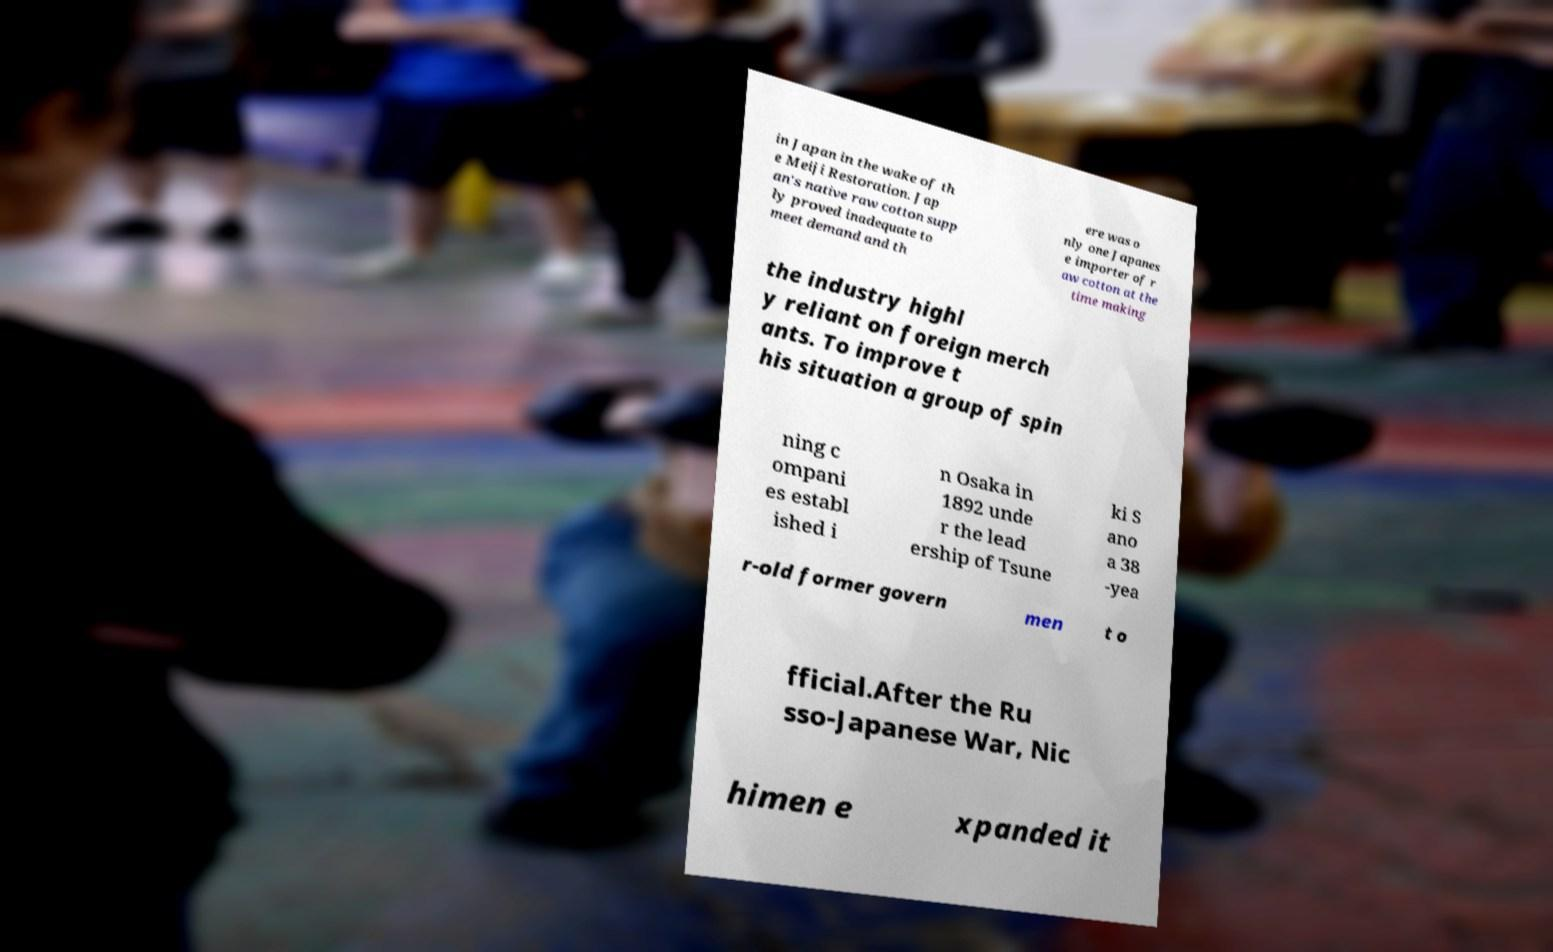Please read and relay the text visible in this image. What does it say? in Japan in the wake of th e Meiji Restoration. Jap an's native raw cotton supp ly proved inadequate to meet demand and th ere was o nly one Japanes e importer of r aw cotton at the time making the industry highl y reliant on foreign merch ants. To improve t his situation a group of spin ning c ompani es establ ished i n Osaka in 1892 unde r the lead ership of Tsune ki S ano a 38 -yea r-old former govern men t o fficial.After the Ru sso-Japanese War, Nic himen e xpanded it 